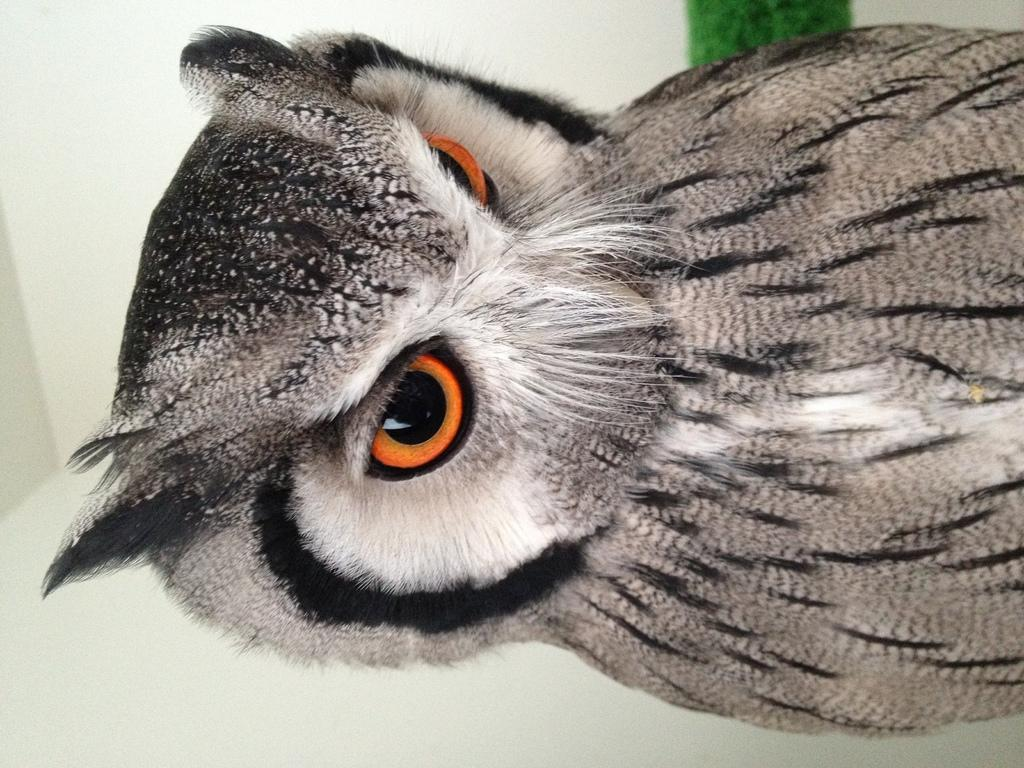What type of animal is in the image? There is an owl in the image. What color is the background of the image? The background of the image appears to be white in color. What type of school does the owl attend in the image? There is no school or indication of education in the image; it simply features an owl. 